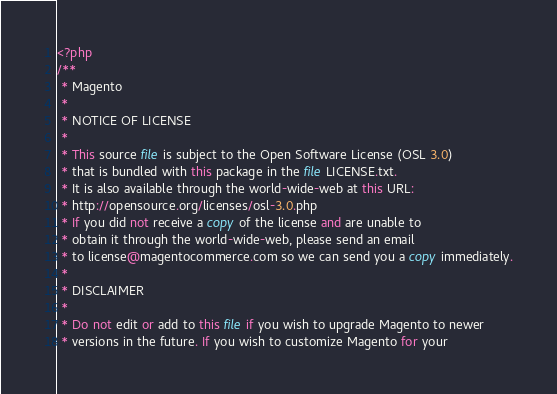Convert code to text. <code><loc_0><loc_0><loc_500><loc_500><_PHP_><?php
/**
 * Magento
 *
 * NOTICE OF LICENSE
 *
 * This source file is subject to the Open Software License (OSL 3.0)
 * that is bundled with this package in the file LICENSE.txt.
 * It is also available through the world-wide-web at this URL:
 * http://opensource.org/licenses/osl-3.0.php
 * If you did not receive a copy of the license and are unable to
 * obtain it through the world-wide-web, please send an email
 * to license@magentocommerce.com so we can send you a copy immediately.
 *
 * DISCLAIMER
 *
 * Do not edit or add to this file if you wish to upgrade Magento to newer
 * versions in the future. If you wish to customize Magento for your</code> 